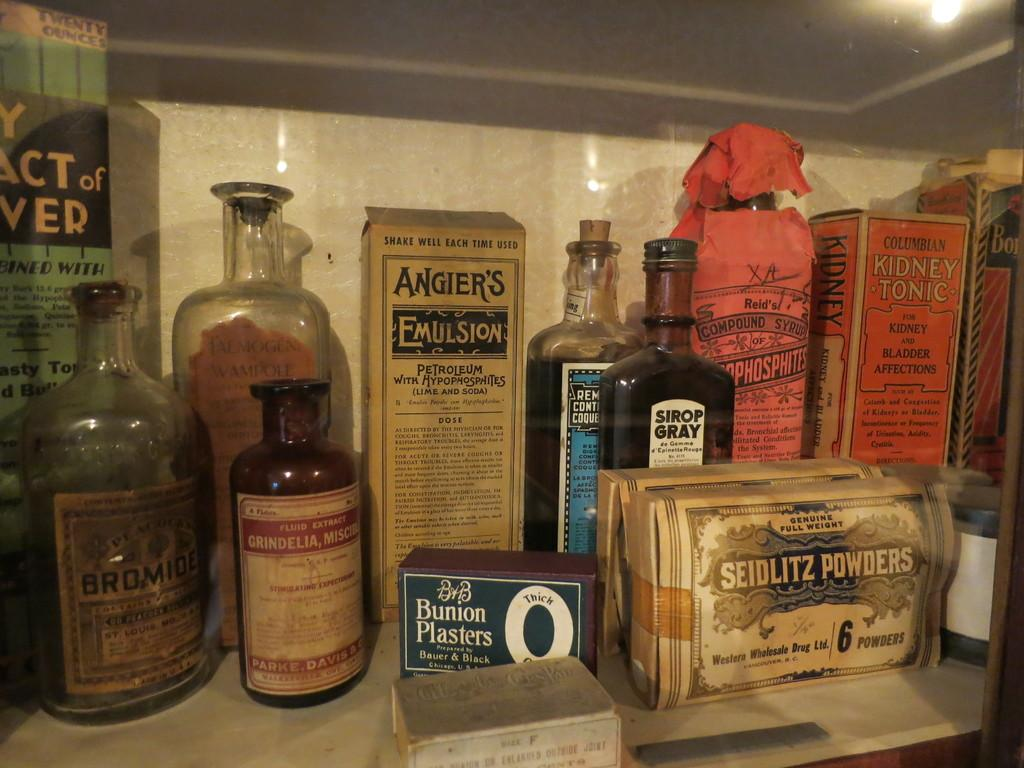What can be seen on the shelf in the image? There are bottles on the shelf in the image. Can you describe the colors of the bottles? The bottles have different colors: white, orange, blue, golden, and black. How does the shelf show respect to the cable in the image? There is no cable present in the image, and the shelf does not show respect to any object in the image. 